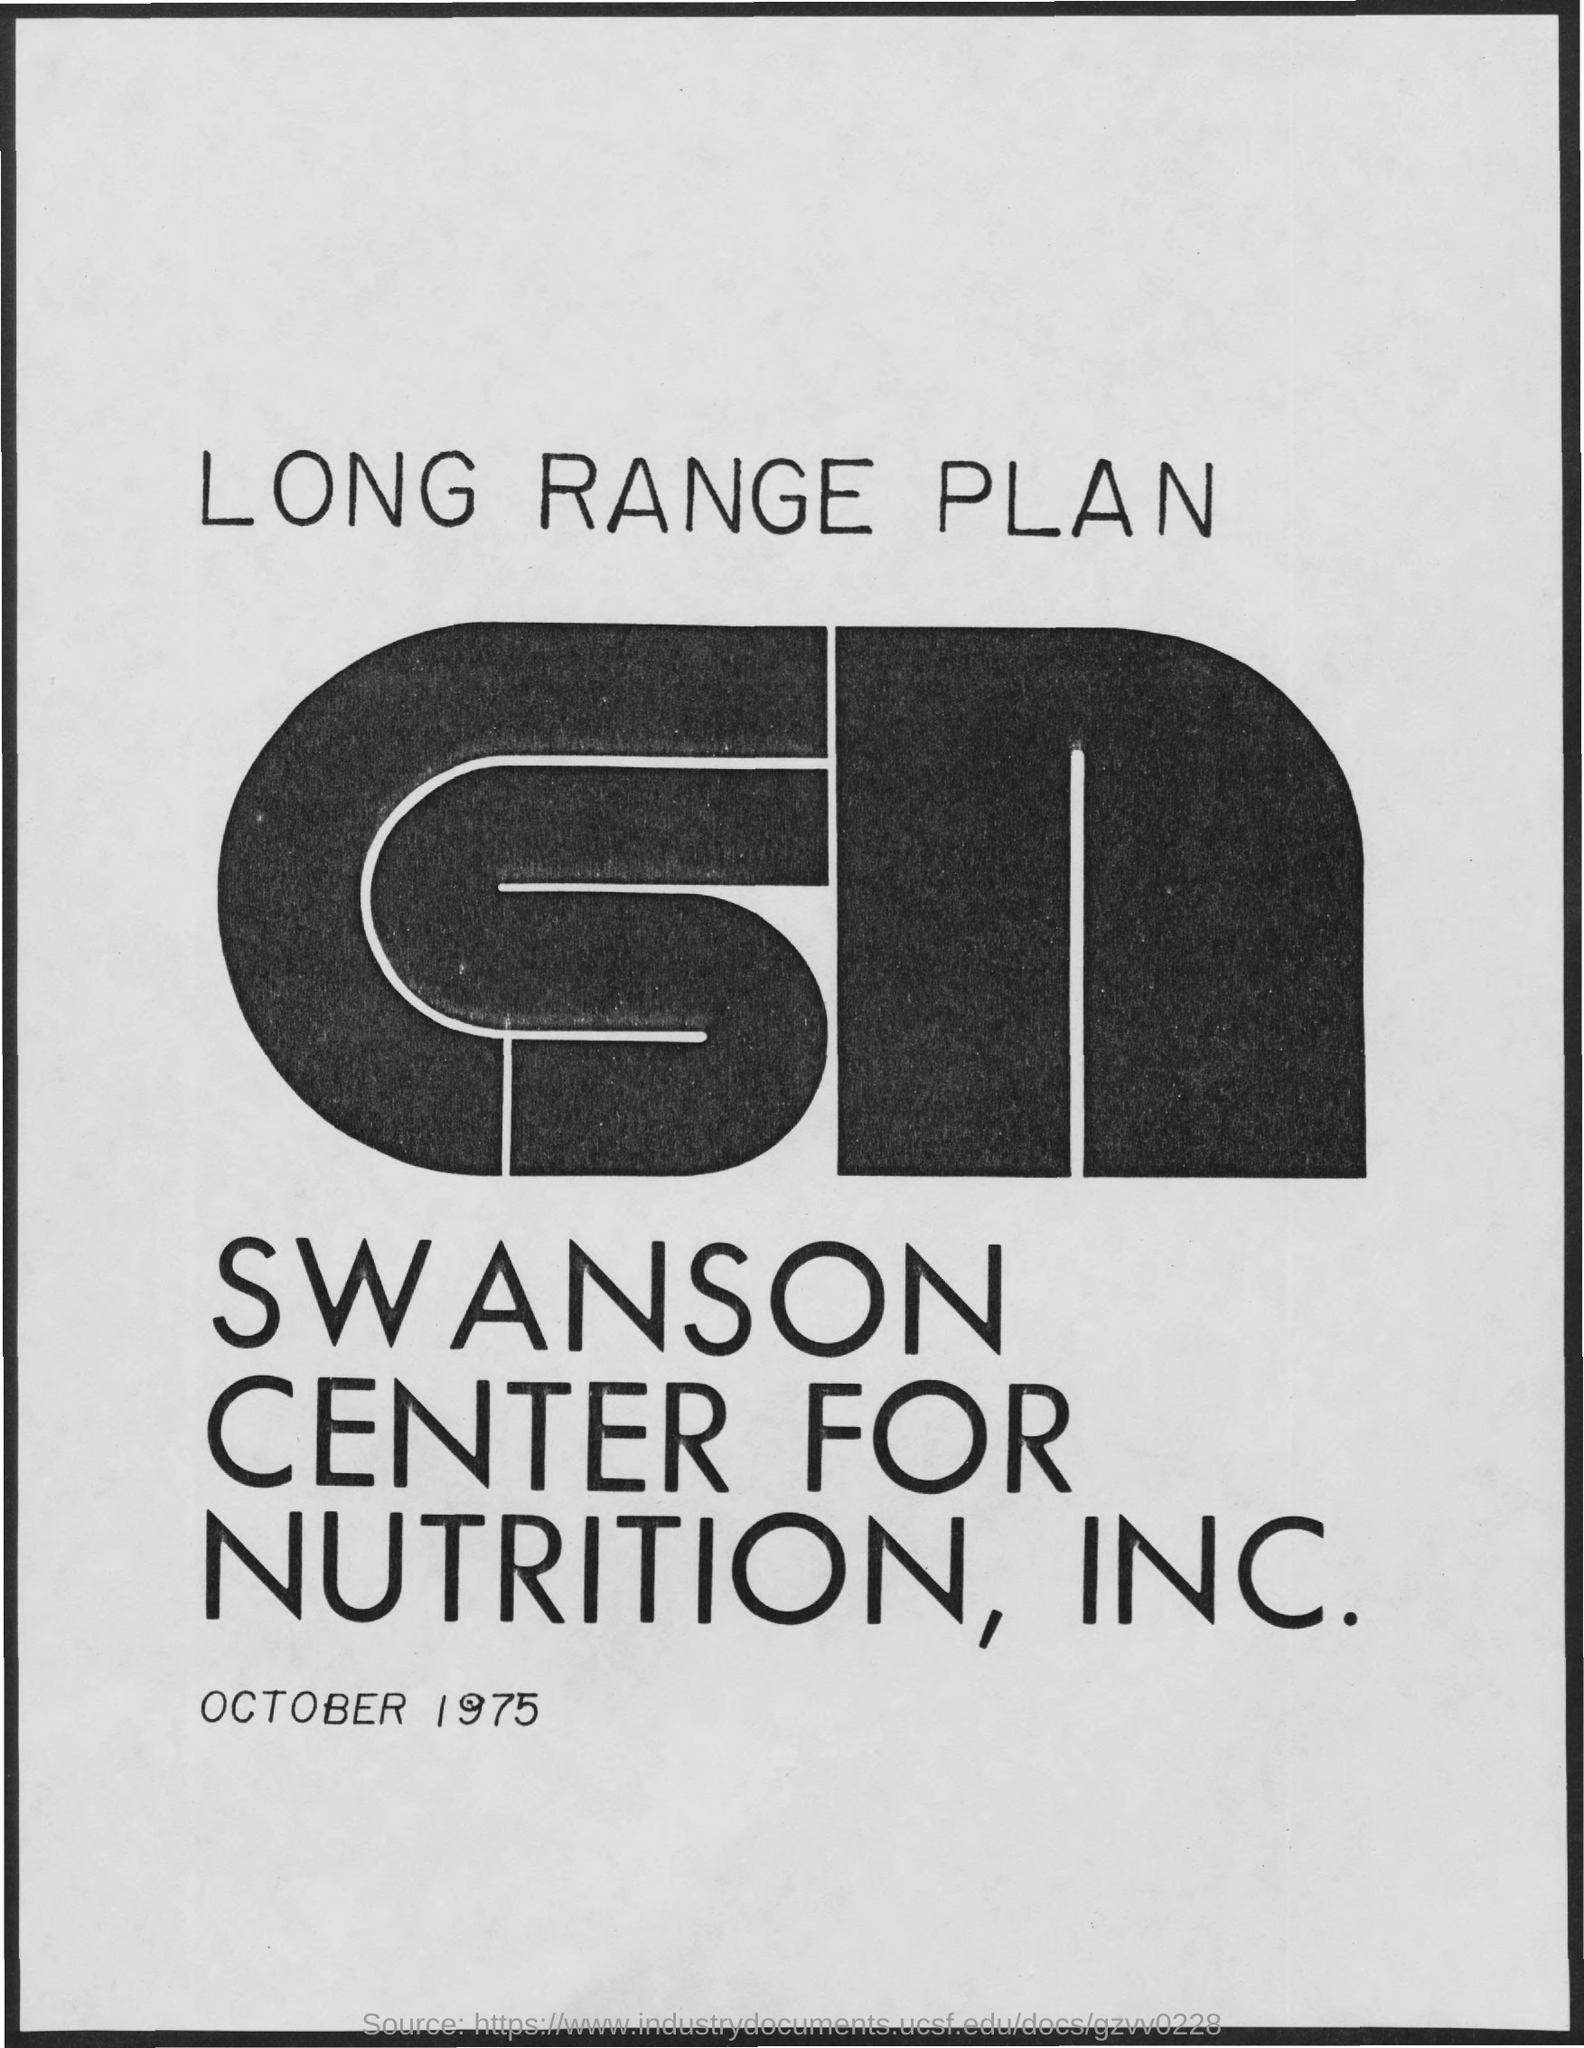Highlight a few significant elements in this photo. The title of the document is the Long Range Plan. The date on the document is October 1975. 